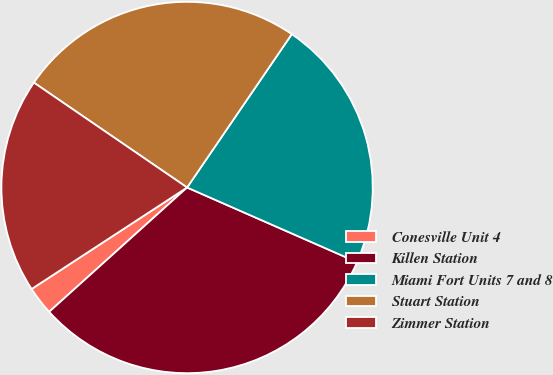<chart> <loc_0><loc_0><loc_500><loc_500><pie_chart><fcel>Conesville Unit 4<fcel>Killen Station<fcel>Miami Fort Units 7 and 8<fcel>Stuart Station<fcel>Zimmer Station<nl><fcel>2.47%<fcel>31.74%<fcel>22.05%<fcel>24.98%<fcel>18.76%<nl></chart> 